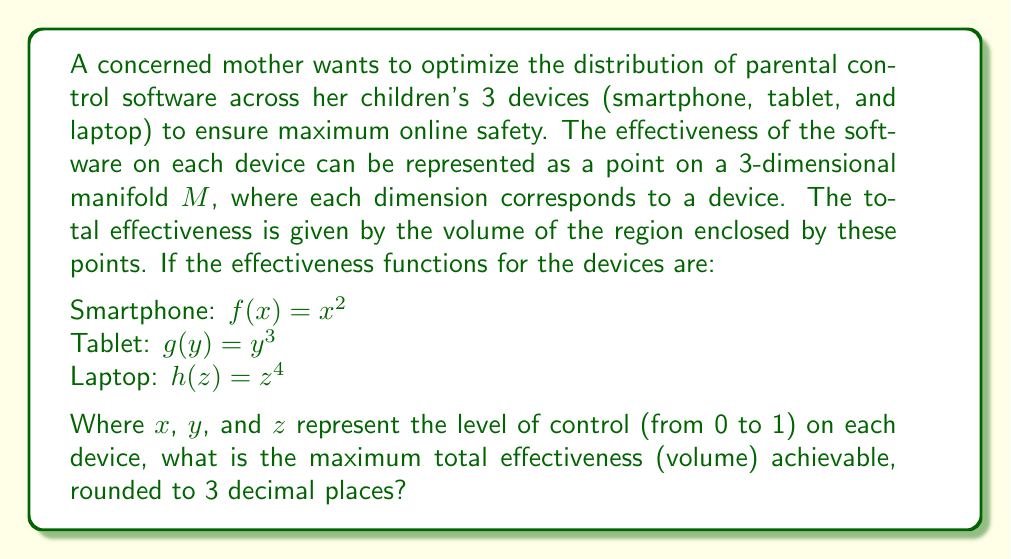Show me your answer to this math problem. To solve this problem, we need to follow these steps:

1) The volume enclosed by the effectiveness functions on the manifold $M$ can be calculated using a triple integral:

   $$V = \iiint_M dxdydz$$

2) The limits of integration are determined by the effectiveness functions:
   
   $$V = \int_0^1 \int_0^{y^{1/3}} \int_0^{x^{1/2}} dzdydx$$

3) Let's solve this integral step by step:

   Inner integral (with respect to $z$):
   $$\int_0^{x^{1/2}} dz = x^{1/2}$$

   Middle integral (with respect to $y$):
   $$\int_0^1 x^{1/2} dy = x^{1/2}$$

   Outer integral (with respect to $x$):
   $$\int_0^1 x^{1/2} dx = \frac{2}{3}x^{3/2}\bigg|_0^1 = \frac{2}{3}$$

4) Therefore, the maximum total effectiveness (volume) is $\frac{2}{3} \approx 0.667$.

This result represents the optimal distribution of parental control software across the three devices, maximizing the overall effectiveness of online safety measures for the children.
Answer: 0.667 